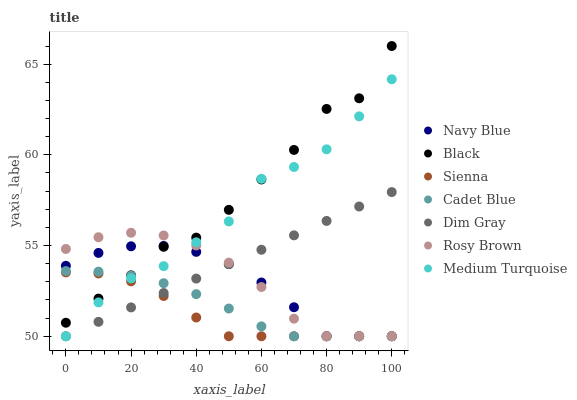Does Sienna have the minimum area under the curve?
Answer yes or no. Yes. Does Black have the maximum area under the curve?
Answer yes or no. Yes. Does Navy Blue have the minimum area under the curve?
Answer yes or no. No. Does Navy Blue have the maximum area under the curve?
Answer yes or no. No. Is Dim Gray the smoothest?
Answer yes or no. Yes. Is Black the roughest?
Answer yes or no. Yes. Is Navy Blue the smoothest?
Answer yes or no. No. Is Navy Blue the roughest?
Answer yes or no. No. Does Dim Gray have the lowest value?
Answer yes or no. Yes. Does Black have the lowest value?
Answer yes or no. No. Does Black have the highest value?
Answer yes or no. Yes. Does Navy Blue have the highest value?
Answer yes or no. No. Is Dim Gray less than Black?
Answer yes or no. Yes. Is Black greater than Dim Gray?
Answer yes or no. Yes. Does Sienna intersect Dim Gray?
Answer yes or no. Yes. Is Sienna less than Dim Gray?
Answer yes or no. No. Is Sienna greater than Dim Gray?
Answer yes or no. No. Does Dim Gray intersect Black?
Answer yes or no. No. 